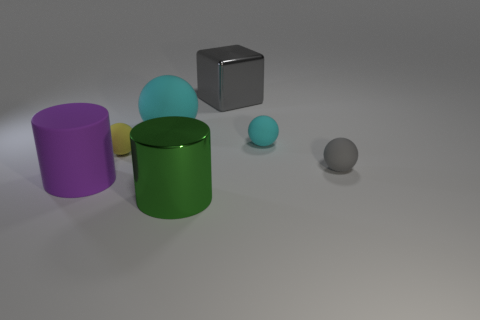Subtract 1 balls. How many balls are left? 3 Add 1 yellow rubber spheres. How many objects exist? 8 Subtract all spheres. How many objects are left? 3 Subtract all brown objects. Subtract all big gray shiny objects. How many objects are left? 6 Add 4 yellow rubber balls. How many yellow rubber balls are left? 5 Add 3 metallic cylinders. How many metallic cylinders exist? 4 Subtract 1 gray balls. How many objects are left? 6 